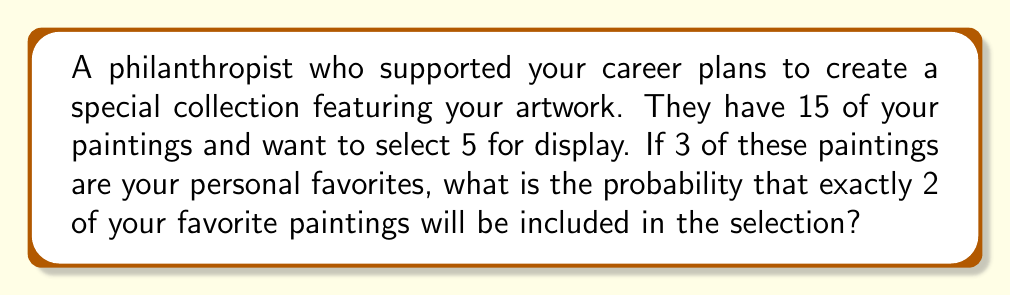Show me your answer to this math problem. Let's approach this step-by-step:

1) First, we need to calculate the total number of ways to select 5 paintings out of 15. This is a combination problem, denoted as $\binom{15}{5}$.

   $$\binom{15}{5} = \frac{15!}{5!(15-5)!} = \frac{15!}{5!10!} = 3003$$

2) Now, we need to calculate the number of ways to select exactly 2 of the 3 favorite paintings and 3 from the remaining 12 paintings.

   - Selecting 2 out of 3 favorite paintings: $\binom{3}{2} = 3$
   - Selecting 3 out of the remaining 12 paintings: $\binom{12}{3} = 220$

3) The total number of favorable outcomes is the product of these two combinations:

   $$3 \times 220 = 660$$

4) The probability is the number of favorable outcomes divided by the total number of possible outcomes:

   $$P(\text{exactly 2 favorites}) = \frac{660}{3003}$$

5) This can be simplified:

   $$\frac{660}{3003} = \frac{220}{1001} \approx 0.2198$$
Answer: $\frac{220}{1001}$ 